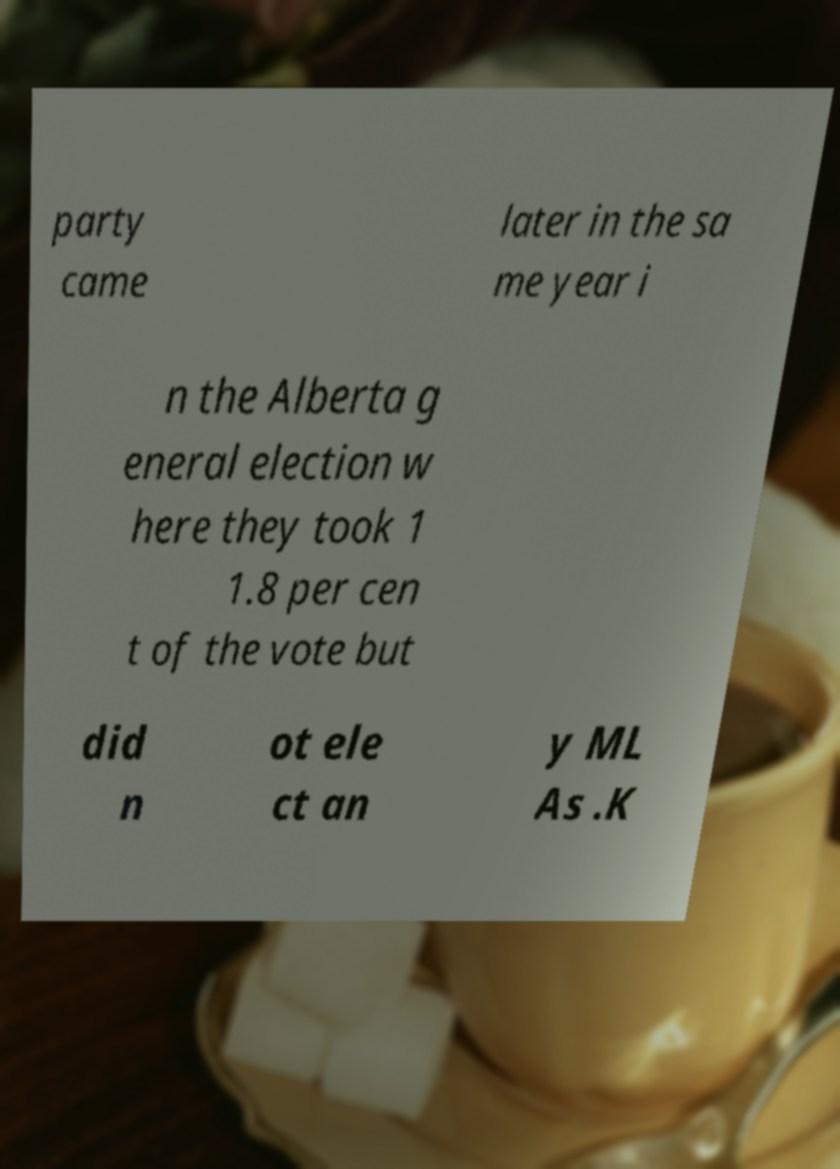Can you accurately transcribe the text from the provided image for me? party came later in the sa me year i n the Alberta g eneral election w here they took 1 1.8 per cen t of the vote but did n ot ele ct an y ML As .K 